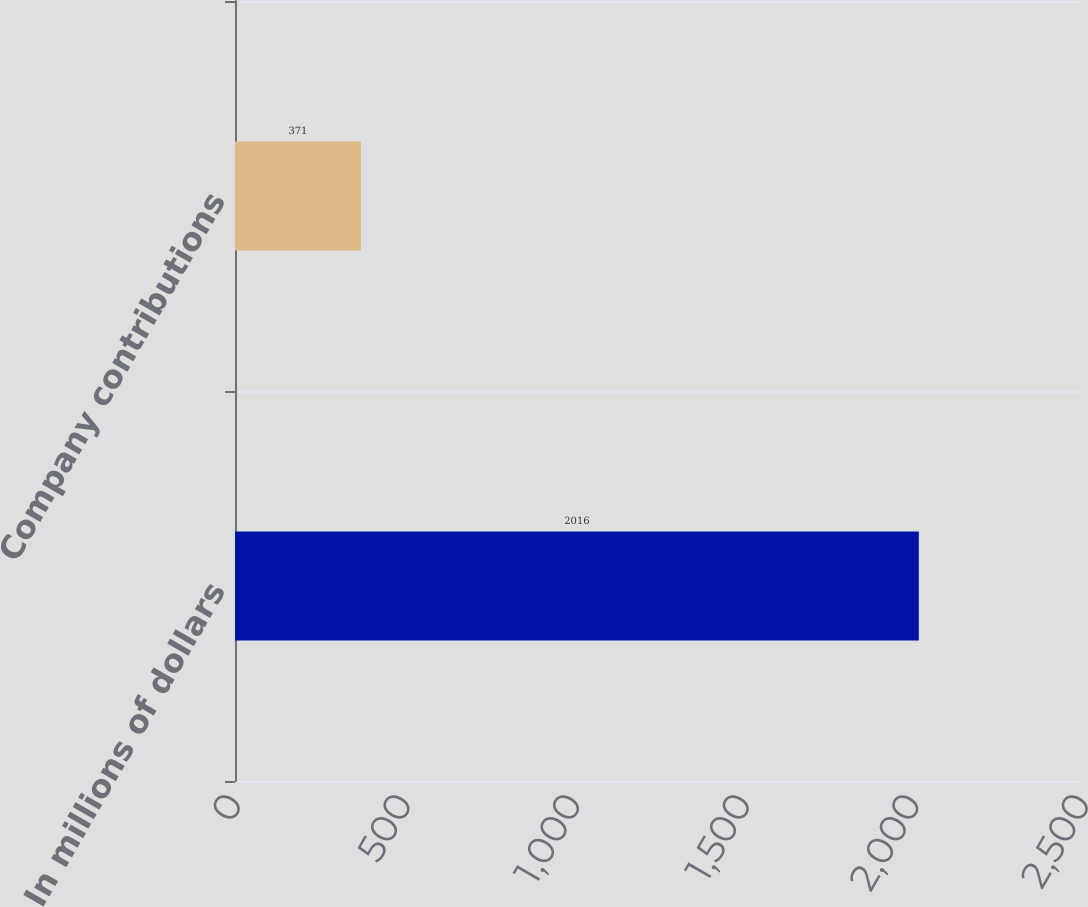Convert chart to OTSL. <chart><loc_0><loc_0><loc_500><loc_500><bar_chart><fcel>In millions of dollars<fcel>Company contributions<nl><fcel>2016<fcel>371<nl></chart> 